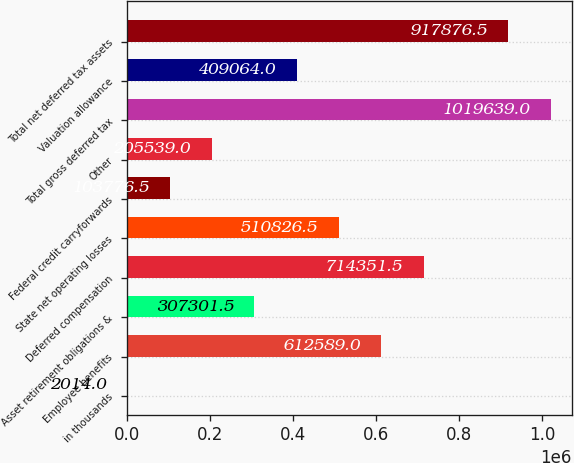Convert chart. <chart><loc_0><loc_0><loc_500><loc_500><bar_chart><fcel>in thousands<fcel>Employee benefits<fcel>Asset retirement obligations &<fcel>Deferred compensation<fcel>State net operating losses<fcel>Federal credit carryforwards<fcel>Other<fcel>Total gross deferred tax<fcel>Valuation allowance<fcel>Total net deferred tax assets<nl><fcel>2014<fcel>612589<fcel>307302<fcel>714352<fcel>510826<fcel>103776<fcel>205539<fcel>1.01964e+06<fcel>409064<fcel>917876<nl></chart> 